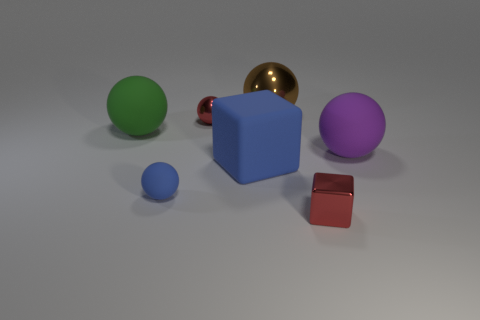Subtract all big brown spheres. How many spheres are left? 4 Add 2 metallic things. How many objects exist? 9 Subtract all purple balls. How many balls are left? 4 Subtract all balls. How many objects are left? 2 Subtract all purple spheres. Subtract all brown cylinders. How many spheres are left? 4 Add 7 tiny brown blocks. How many tiny brown blocks exist? 7 Subtract 0 gray balls. How many objects are left? 7 Subtract all matte things. Subtract all cyan metal things. How many objects are left? 3 Add 7 big metallic spheres. How many big metallic spheres are left? 8 